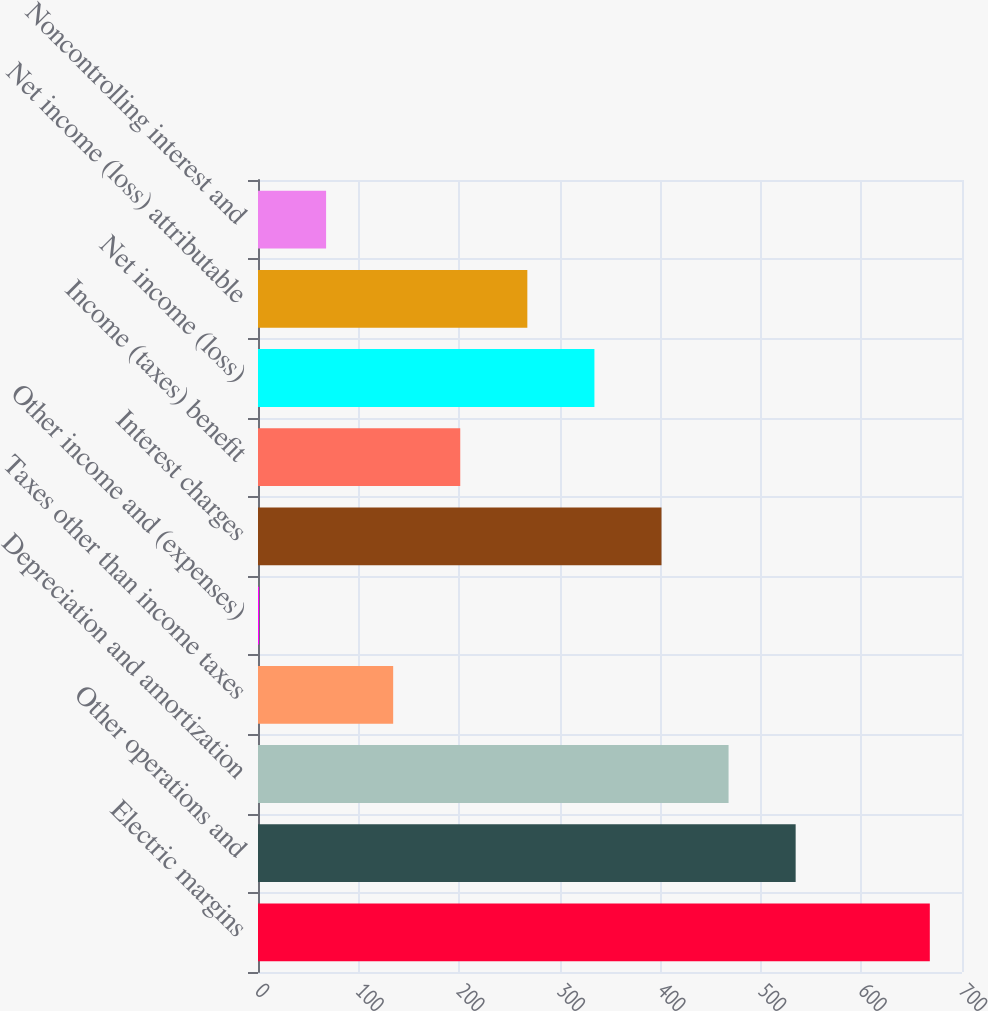Convert chart. <chart><loc_0><loc_0><loc_500><loc_500><bar_chart><fcel>Electric margins<fcel>Other operations and<fcel>Depreciation and amortization<fcel>Taxes other than income taxes<fcel>Other income and (expenses)<fcel>Interest charges<fcel>Income (taxes) benefit<fcel>Net income (loss)<fcel>Net income (loss) attributable<fcel>Noncontrolling interest and<nl><fcel>668<fcel>534.6<fcel>467.9<fcel>134.4<fcel>1<fcel>401.2<fcel>201.1<fcel>334.5<fcel>267.8<fcel>67.7<nl></chart> 